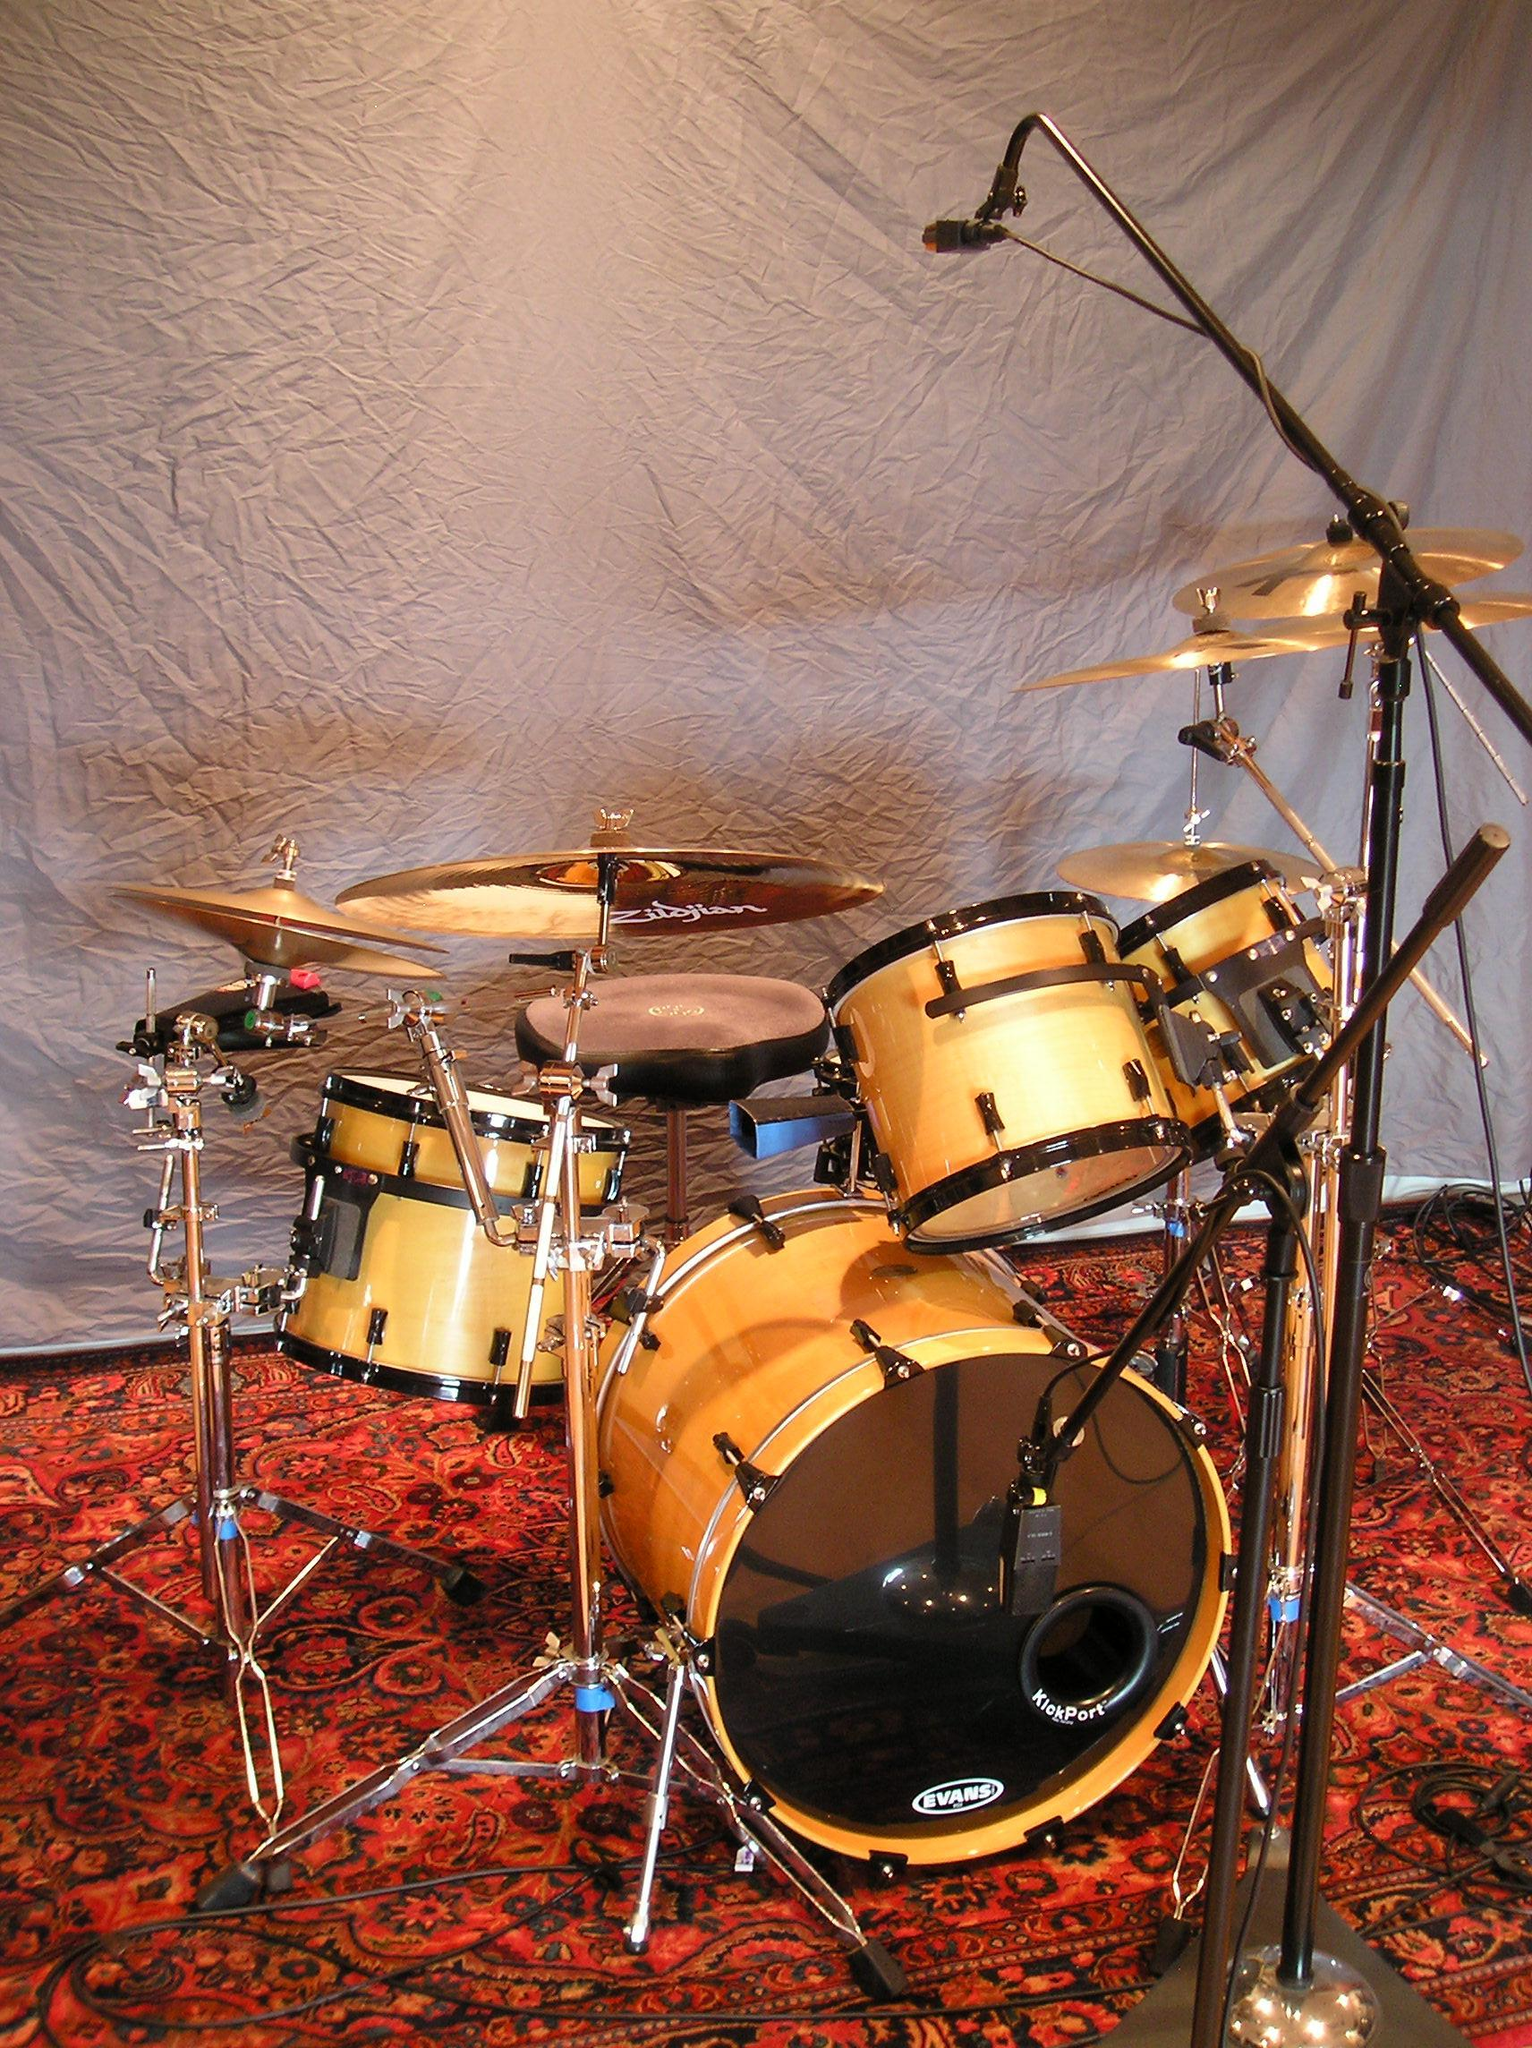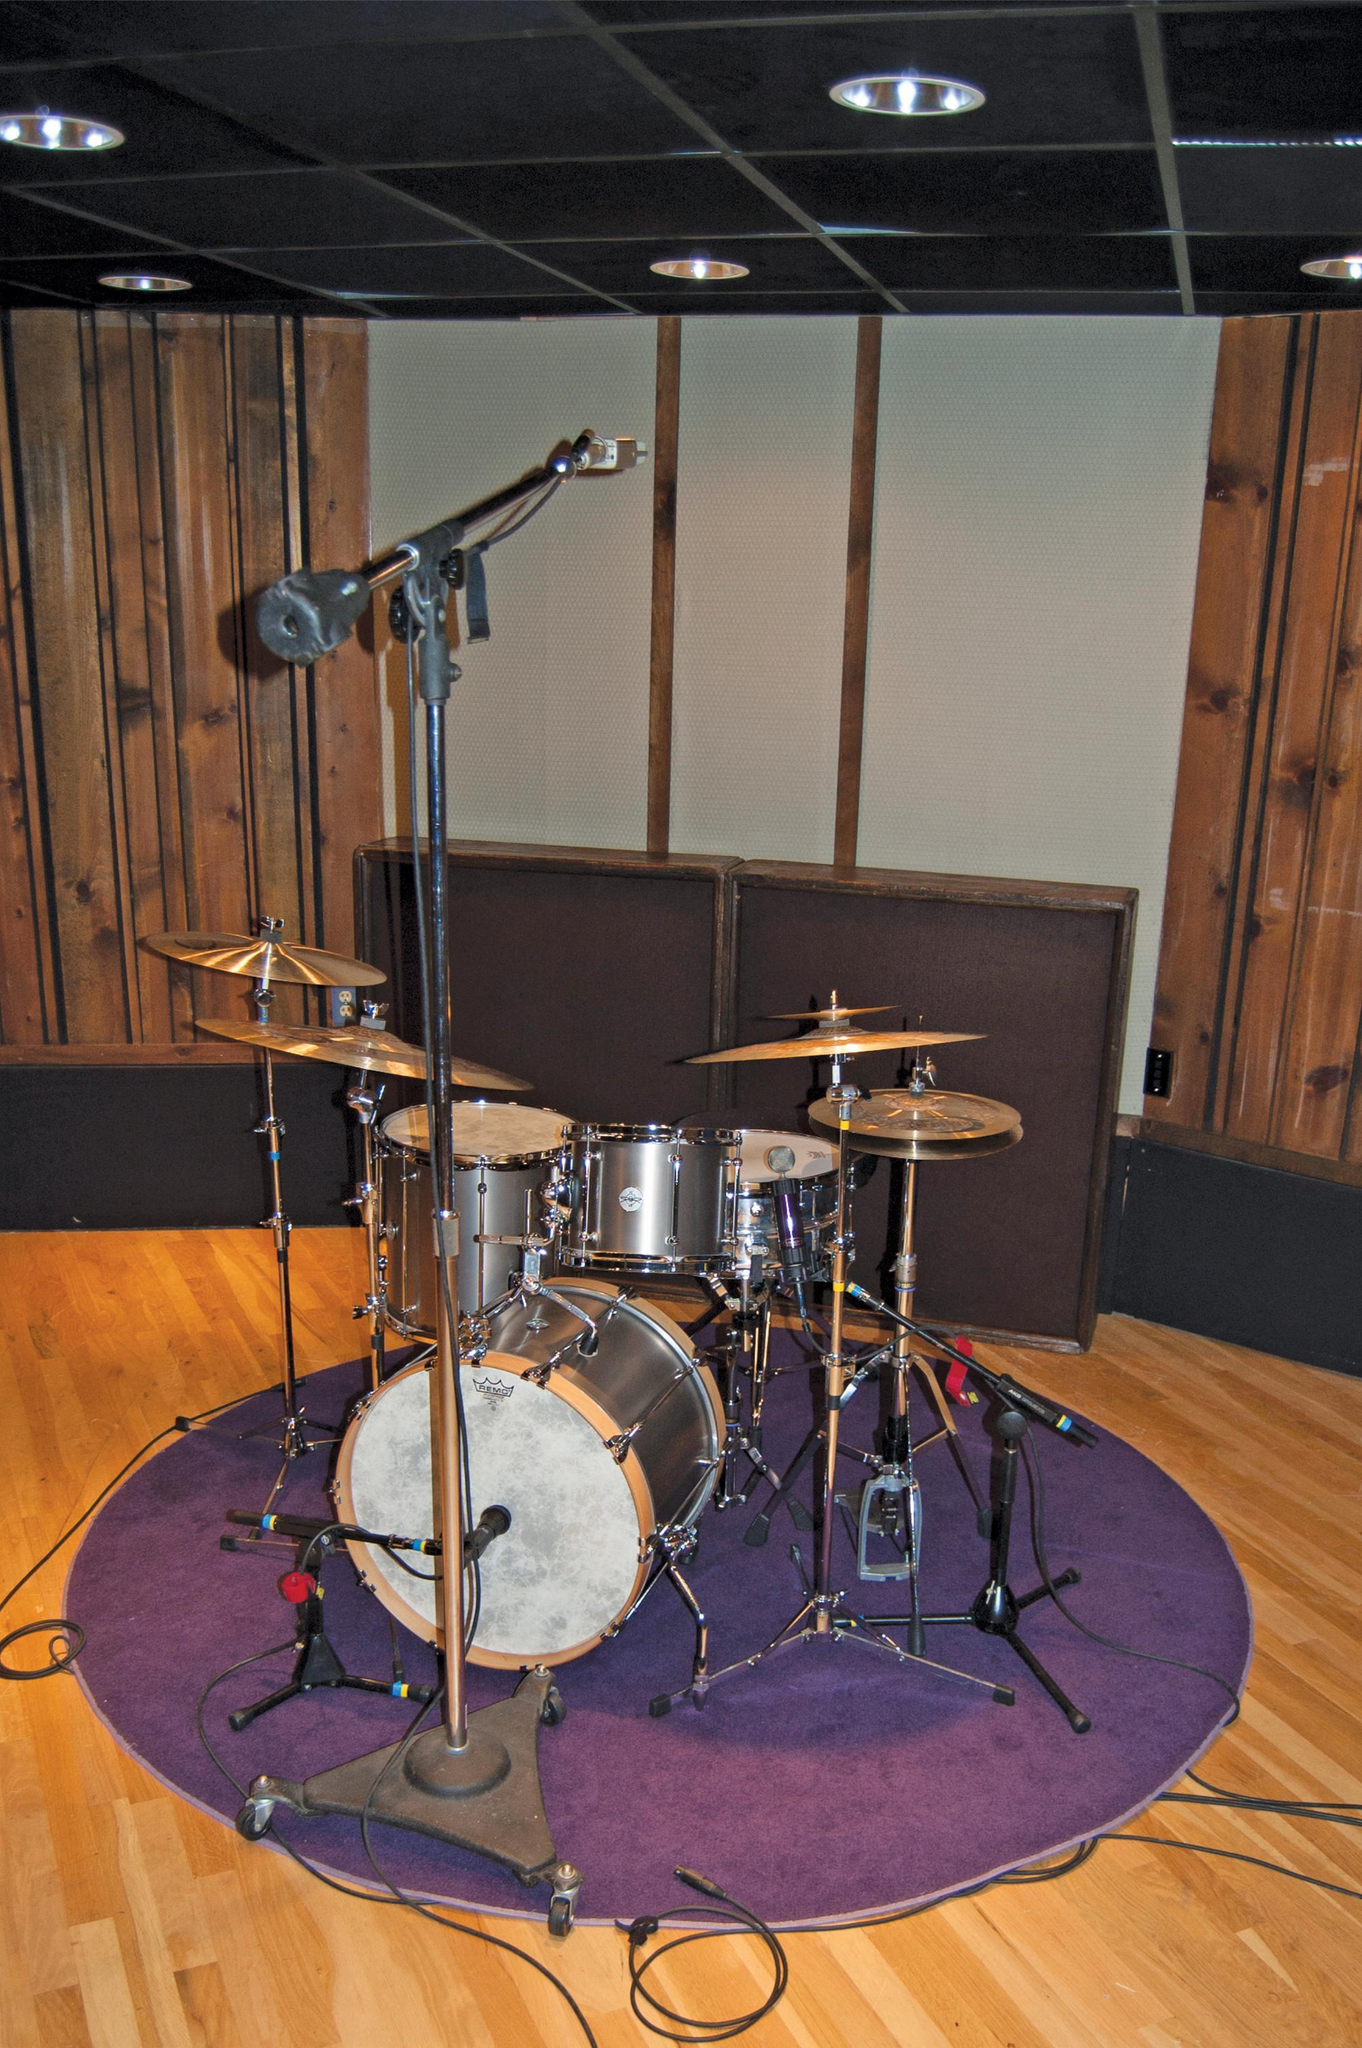The first image is the image on the left, the second image is the image on the right. Assess this claim about the two images: "The drumset sits on a rectangular rug in one of the images.". Correct or not? Answer yes or no. No. The first image is the image on the left, the second image is the image on the right. Considering the images on both sides, is "There is a kick drum with white skin." valid? Answer yes or no. Yes. 